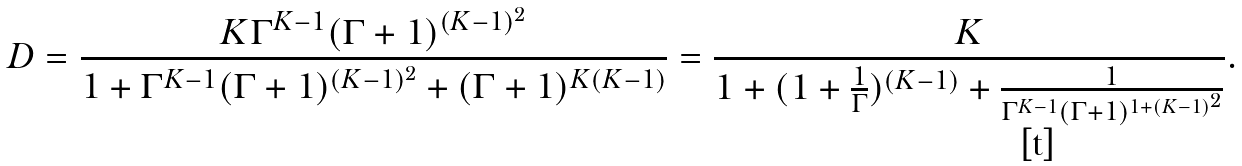Convert formula to latex. <formula><loc_0><loc_0><loc_500><loc_500>D = \frac { K \Gamma ^ { K - 1 } ( \Gamma + 1 ) ^ { ( K - 1 ) ^ { 2 } } } { 1 + \Gamma ^ { K - 1 } ( \Gamma + 1 ) ^ { ( K - 1 ) ^ { 2 } } + ( \Gamma + 1 ) ^ { K ( K - 1 ) } } = \frac { K } { 1 + ( 1 + \frac { 1 } { \Gamma } ) ^ { ( K - 1 ) } + \frac { 1 } { \Gamma ^ { K - 1 } ( \Gamma + 1 ) ^ { 1 + ( K - 1 ) ^ { 2 } } } } .</formula> 